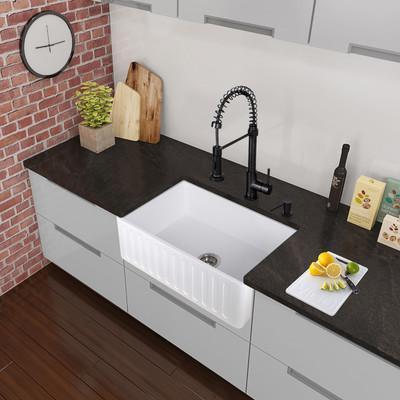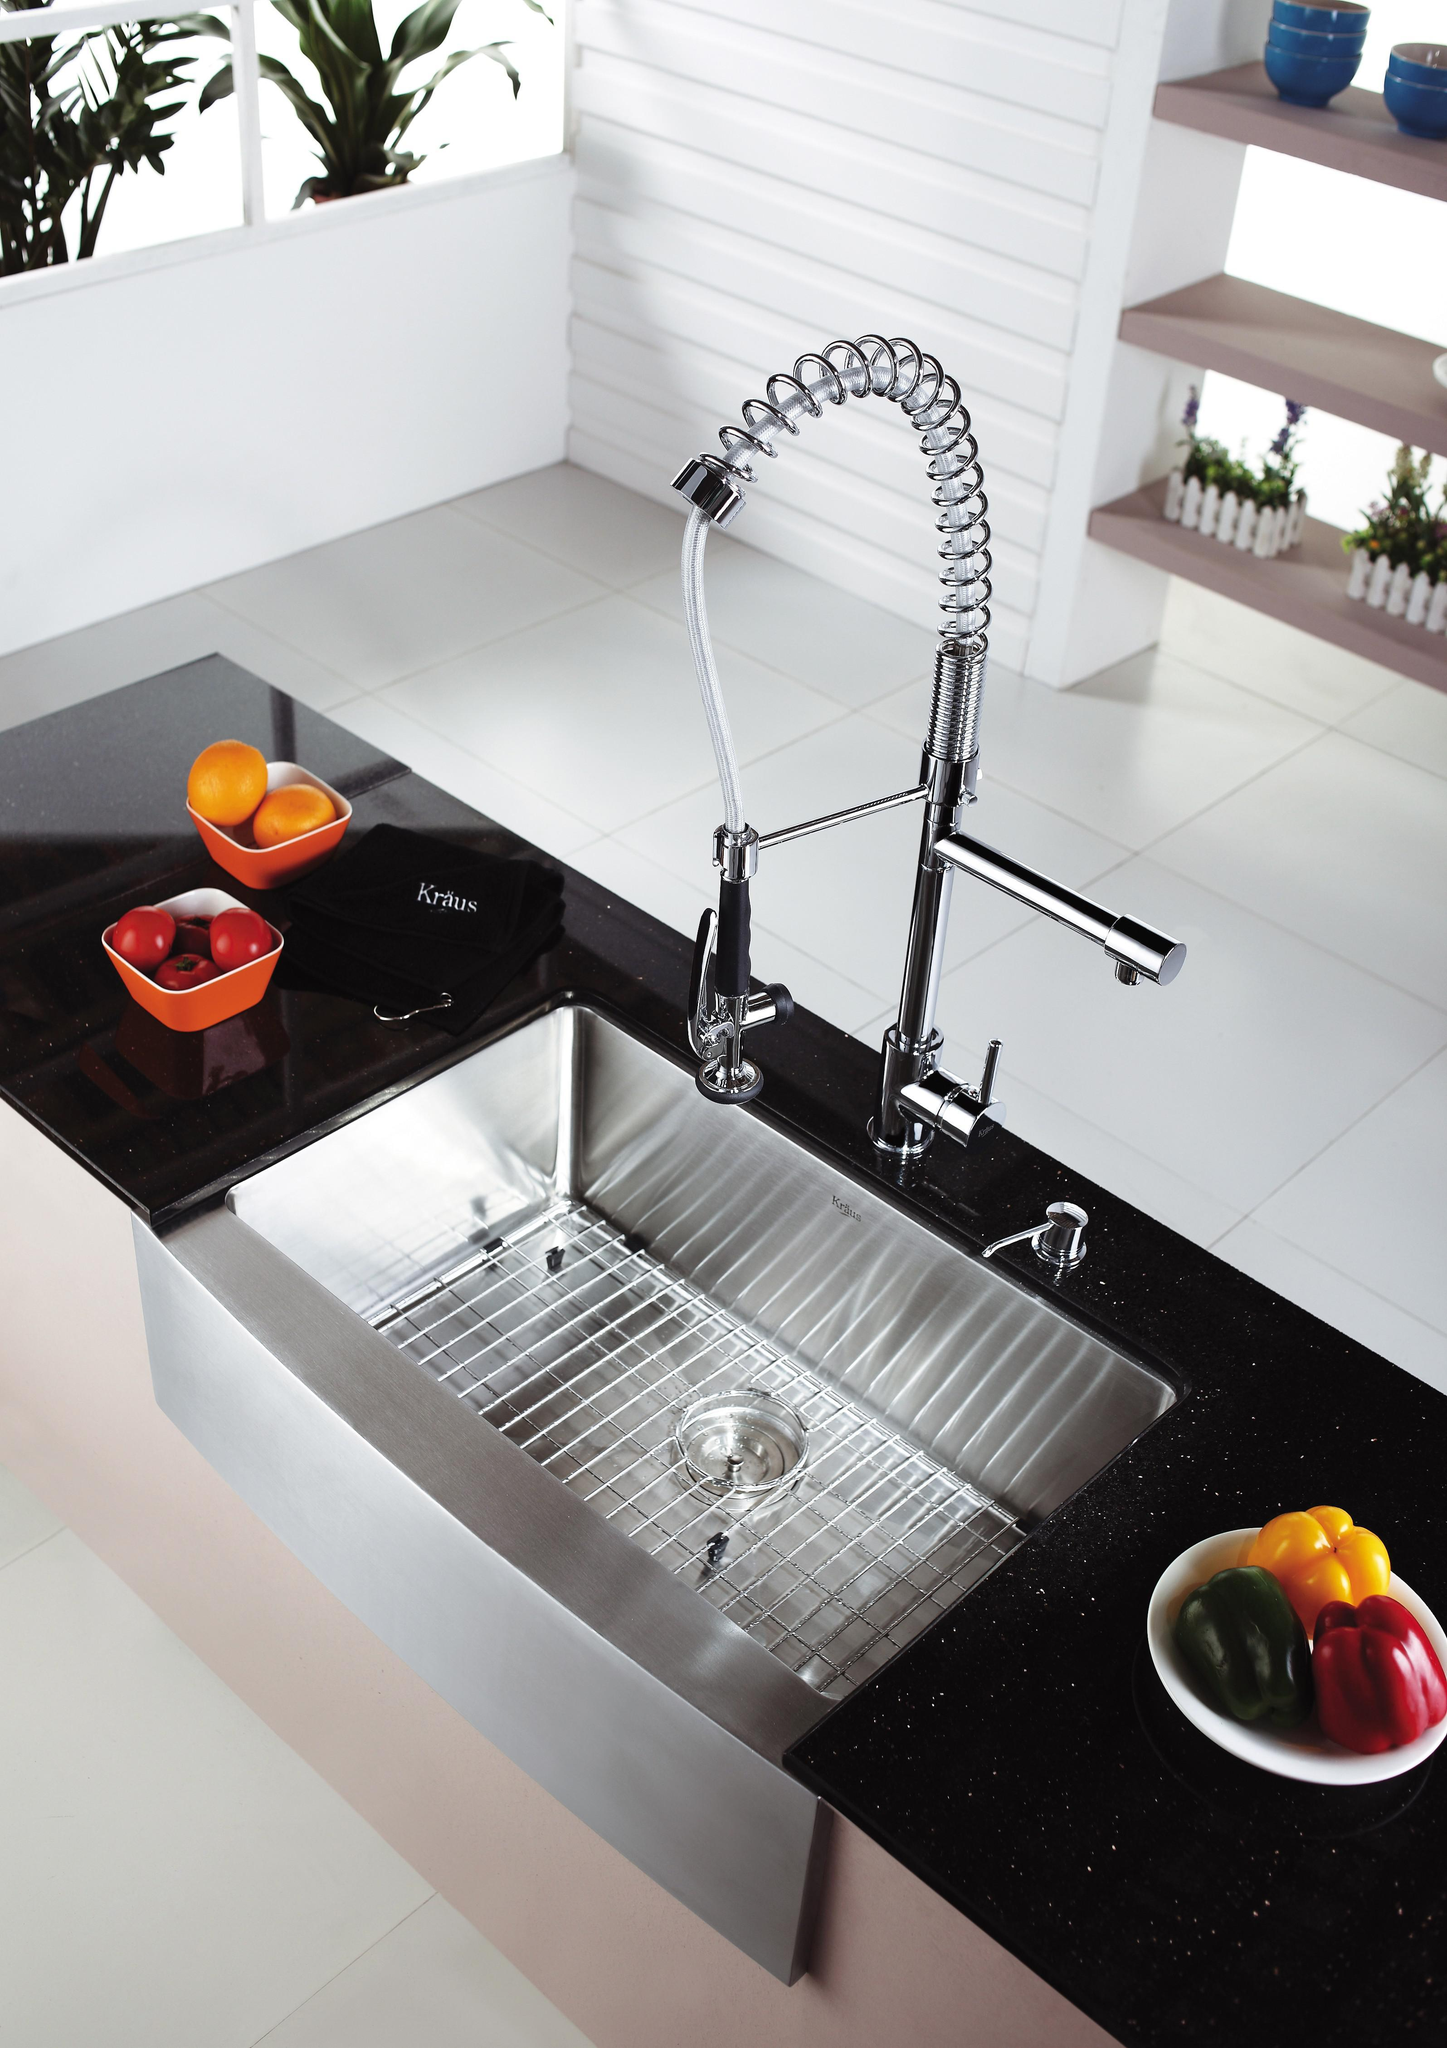The first image is the image on the left, the second image is the image on the right. Examine the images to the left and right. Is the description "The right image shows a single-basin rectangular sink with a wire rack inside it." accurate? Answer yes or no. Yes. 